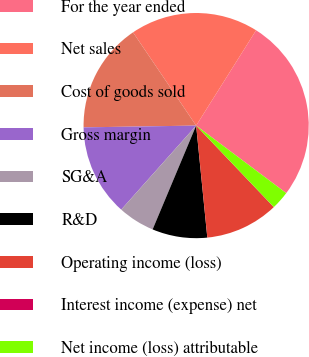Convert chart to OTSL. <chart><loc_0><loc_0><loc_500><loc_500><pie_chart><fcel>For the year ended<fcel>Net sales<fcel>Cost of goods sold<fcel>Gross margin<fcel>SG&A<fcel>R&D<fcel>Operating income (loss)<fcel>Interest income (expense) net<fcel>Net income (loss) attributable<nl><fcel>26.3%<fcel>18.41%<fcel>15.78%<fcel>13.16%<fcel>5.27%<fcel>7.9%<fcel>10.53%<fcel>0.01%<fcel>2.64%<nl></chart> 